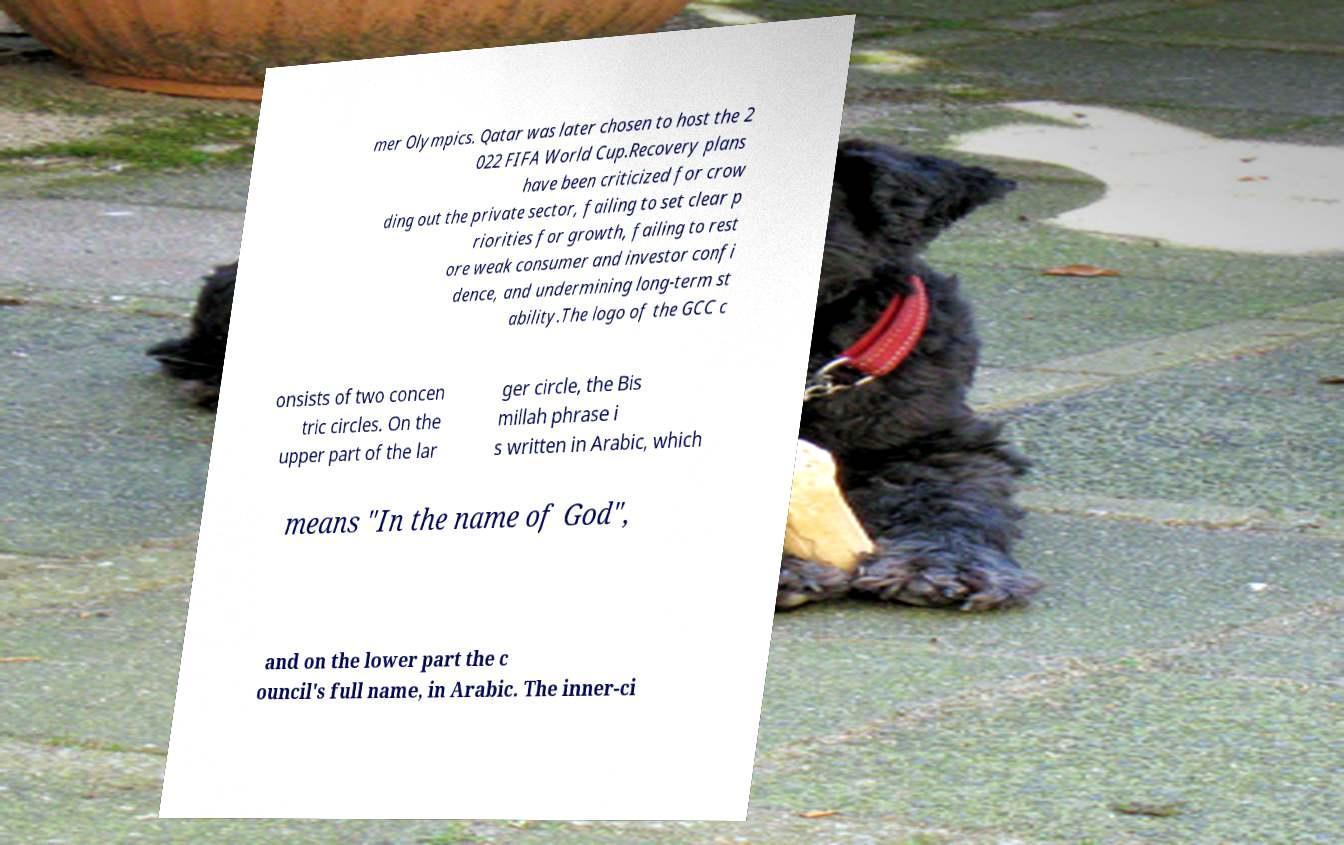Could you extract and type out the text from this image? mer Olympics. Qatar was later chosen to host the 2 022 FIFA World Cup.Recovery plans have been criticized for crow ding out the private sector, failing to set clear p riorities for growth, failing to rest ore weak consumer and investor confi dence, and undermining long-term st ability.The logo of the GCC c onsists of two concen tric circles. On the upper part of the lar ger circle, the Bis millah phrase i s written in Arabic, which means "In the name of God", and on the lower part the c ouncil's full name, in Arabic. The inner-ci 